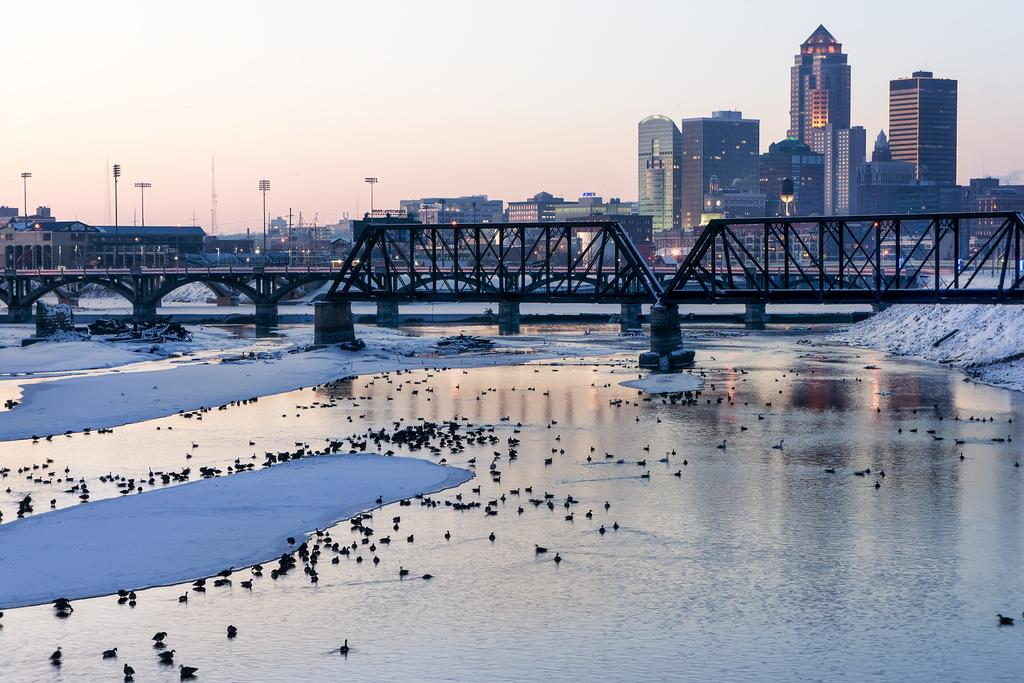What structure is featured in the image? There is a bridge in the image. What is the bridge positioned over? The bridge is over water. What type of animals can be seen in the image? There are birds visible in the image. What type of structures are near the water? There are buildings near the water. What type of utility infrastructure is present in the image? Electric poles with lights are present in the image. What part of the natural environment is visible in the image? The sky is visible in the image. What type of fish is the manager holding in the image? There is no fish or manager present in the image. How many hens are visible on the bridge in the image? There are no hens present in the image; only birds are visible. 